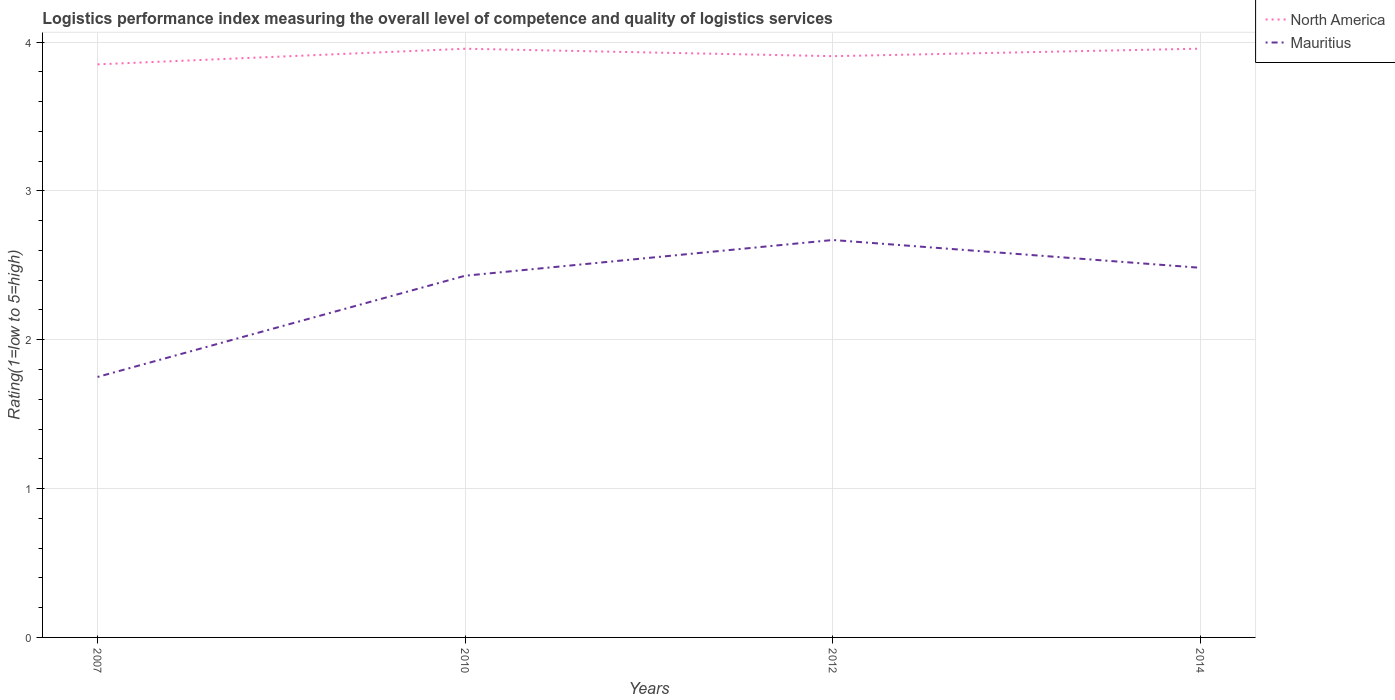Does the line corresponding to North America intersect with the line corresponding to Mauritius?
Keep it short and to the point. No. Is the number of lines equal to the number of legend labels?
Your response must be concise. Yes. Across all years, what is the maximum Logistic performance index in Mauritius?
Keep it short and to the point. 1.75. What is the total Logistic performance index in North America in the graph?
Your answer should be very brief. -0.11. What is the difference between the highest and the second highest Logistic performance index in Mauritius?
Give a very brief answer. 0.92. How many lines are there?
Provide a short and direct response. 2. How many years are there in the graph?
Your answer should be very brief. 4. Does the graph contain any zero values?
Provide a short and direct response. No. Does the graph contain grids?
Your answer should be compact. Yes. Where does the legend appear in the graph?
Your answer should be compact. Top right. What is the title of the graph?
Keep it short and to the point. Logistics performance index measuring the overall level of competence and quality of logistics services. What is the label or title of the X-axis?
Your response must be concise. Years. What is the label or title of the Y-axis?
Your response must be concise. Rating(1=low to 5=high). What is the Rating(1=low to 5=high) of North America in 2007?
Give a very brief answer. 3.85. What is the Rating(1=low to 5=high) of Mauritius in 2007?
Give a very brief answer. 1.75. What is the Rating(1=low to 5=high) of North America in 2010?
Make the answer very short. 3.96. What is the Rating(1=low to 5=high) of Mauritius in 2010?
Give a very brief answer. 2.43. What is the Rating(1=low to 5=high) of North America in 2012?
Your response must be concise. 3.9. What is the Rating(1=low to 5=high) of Mauritius in 2012?
Provide a succinct answer. 2.67. What is the Rating(1=low to 5=high) in North America in 2014?
Offer a terse response. 3.96. What is the Rating(1=low to 5=high) in Mauritius in 2014?
Keep it short and to the point. 2.48. Across all years, what is the maximum Rating(1=low to 5=high) in North America?
Offer a terse response. 3.96. Across all years, what is the maximum Rating(1=low to 5=high) of Mauritius?
Provide a short and direct response. 2.67. Across all years, what is the minimum Rating(1=low to 5=high) in North America?
Your answer should be compact. 3.85. What is the total Rating(1=low to 5=high) of North America in the graph?
Your response must be concise. 15.67. What is the total Rating(1=low to 5=high) in Mauritius in the graph?
Keep it short and to the point. 9.33. What is the difference between the Rating(1=low to 5=high) of North America in 2007 and that in 2010?
Provide a succinct answer. -0.1. What is the difference between the Rating(1=low to 5=high) of Mauritius in 2007 and that in 2010?
Keep it short and to the point. -0.68. What is the difference between the Rating(1=low to 5=high) in North America in 2007 and that in 2012?
Provide a short and direct response. -0.06. What is the difference between the Rating(1=low to 5=high) in Mauritius in 2007 and that in 2012?
Your answer should be compact. -0.92. What is the difference between the Rating(1=low to 5=high) in North America in 2007 and that in 2014?
Your answer should be compact. -0.11. What is the difference between the Rating(1=low to 5=high) of Mauritius in 2007 and that in 2014?
Your answer should be very brief. -0.73. What is the difference between the Rating(1=low to 5=high) in Mauritius in 2010 and that in 2012?
Your answer should be compact. -0.24. What is the difference between the Rating(1=low to 5=high) in North America in 2010 and that in 2014?
Give a very brief answer. -0. What is the difference between the Rating(1=low to 5=high) of Mauritius in 2010 and that in 2014?
Offer a very short reply. -0.05. What is the difference between the Rating(1=low to 5=high) in North America in 2012 and that in 2014?
Ensure brevity in your answer.  -0.05. What is the difference between the Rating(1=low to 5=high) of Mauritius in 2012 and that in 2014?
Your response must be concise. 0.19. What is the difference between the Rating(1=low to 5=high) in North America in 2007 and the Rating(1=low to 5=high) in Mauritius in 2010?
Ensure brevity in your answer.  1.42. What is the difference between the Rating(1=low to 5=high) in North America in 2007 and the Rating(1=low to 5=high) in Mauritius in 2012?
Your answer should be very brief. 1.18. What is the difference between the Rating(1=low to 5=high) of North America in 2007 and the Rating(1=low to 5=high) of Mauritius in 2014?
Ensure brevity in your answer.  1.37. What is the difference between the Rating(1=low to 5=high) of North America in 2010 and the Rating(1=low to 5=high) of Mauritius in 2012?
Offer a very short reply. 1.28. What is the difference between the Rating(1=low to 5=high) in North America in 2010 and the Rating(1=low to 5=high) in Mauritius in 2014?
Provide a succinct answer. 1.47. What is the difference between the Rating(1=low to 5=high) of North America in 2012 and the Rating(1=low to 5=high) of Mauritius in 2014?
Your answer should be very brief. 1.42. What is the average Rating(1=low to 5=high) of North America per year?
Provide a succinct answer. 3.92. What is the average Rating(1=low to 5=high) in Mauritius per year?
Your answer should be compact. 2.33. In the year 2010, what is the difference between the Rating(1=low to 5=high) in North America and Rating(1=low to 5=high) in Mauritius?
Make the answer very short. 1.52. In the year 2012, what is the difference between the Rating(1=low to 5=high) in North America and Rating(1=low to 5=high) in Mauritius?
Keep it short and to the point. 1.24. In the year 2014, what is the difference between the Rating(1=low to 5=high) in North America and Rating(1=low to 5=high) in Mauritius?
Give a very brief answer. 1.47. What is the ratio of the Rating(1=low to 5=high) of North America in 2007 to that in 2010?
Offer a terse response. 0.97. What is the ratio of the Rating(1=low to 5=high) in Mauritius in 2007 to that in 2010?
Offer a very short reply. 0.72. What is the ratio of the Rating(1=low to 5=high) in North America in 2007 to that in 2012?
Make the answer very short. 0.99. What is the ratio of the Rating(1=low to 5=high) of Mauritius in 2007 to that in 2012?
Ensure brevity in your answer.  0.66. What is the ratio of the Rating(1=low to 5=high) of North America in 2007 to that in 2014?
Offer a very short reply. 0.97. What is the ratio of the Rating(1=low to 5=high) of Mauritius in 2007 to that in 2014?
Give a very brief answer. 0.7. What is the ratio of the Rating(1=low to 5=high) in North America in 2010 to that in 2012?
Offer a terse response. 1.01. What is the ratio of the Rating(1=low to 5=high) of Mauritius in 2010 to that in 2012?
Offer a very short reply. 0.91. What is the ratio of the Rating(1=low to 5=high) of North America in 2010 to that in 2014?
Ensure brevity in your answer.  1. What is the ratio of the Rating(1=low to 5=high) of Mauritius in 2010 to that in 2014?
Provide a short and direct response. 0.98. What is the ratio of the Rating(1=low to 5=high) of North America in 2012 to that in 2014?
Your answer should be very brief. 0.99. What is the ratio of the Rating(1=low to 5=high) of Mauritius in 2012 to that in 2014?
Keep it short and to the point. 1.08. What is the difference between the highest and the second highest Rating(1=low to 5=high) in North America?
Offer a terse response. 0. What is the difference between the highest and the second highest Rating(1=low to 5=high) of Mauritius?
Ensure brevity in your answer.  0.19. What is the difference between the highest and the lowest Rating(1=low to 5=high) of North America?
Your answer should be very brief. 0.11. What is the difference between the highest and the lowest Rating(1=low to 5=high) in Mauritius?
Make the answer very short. 0.92. 